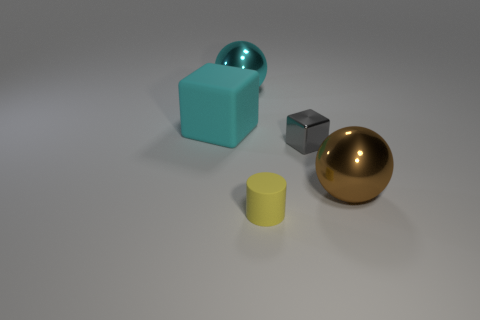Add 4 big brown metal objects. How many objects exist? 9 Subtract all cylinders. How many objects are left? 4 Add 1 large objects. How many large objects exist? 4 Subtract 0 purple blocks. How many objects are left? 5 Subtract all green matte cylinders. Subtract all large brown balls. How many objects are left? 4 Add 1 large brown shiny objects. How many large brown shiny objects are left? 2 